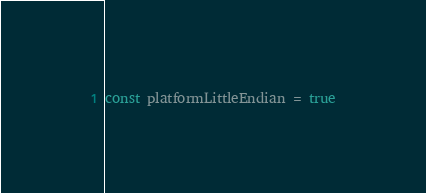<code> <loc_0><loc_0><loc_500><loc_500><_Go_>
const platformLittleEndian = true
</code> 